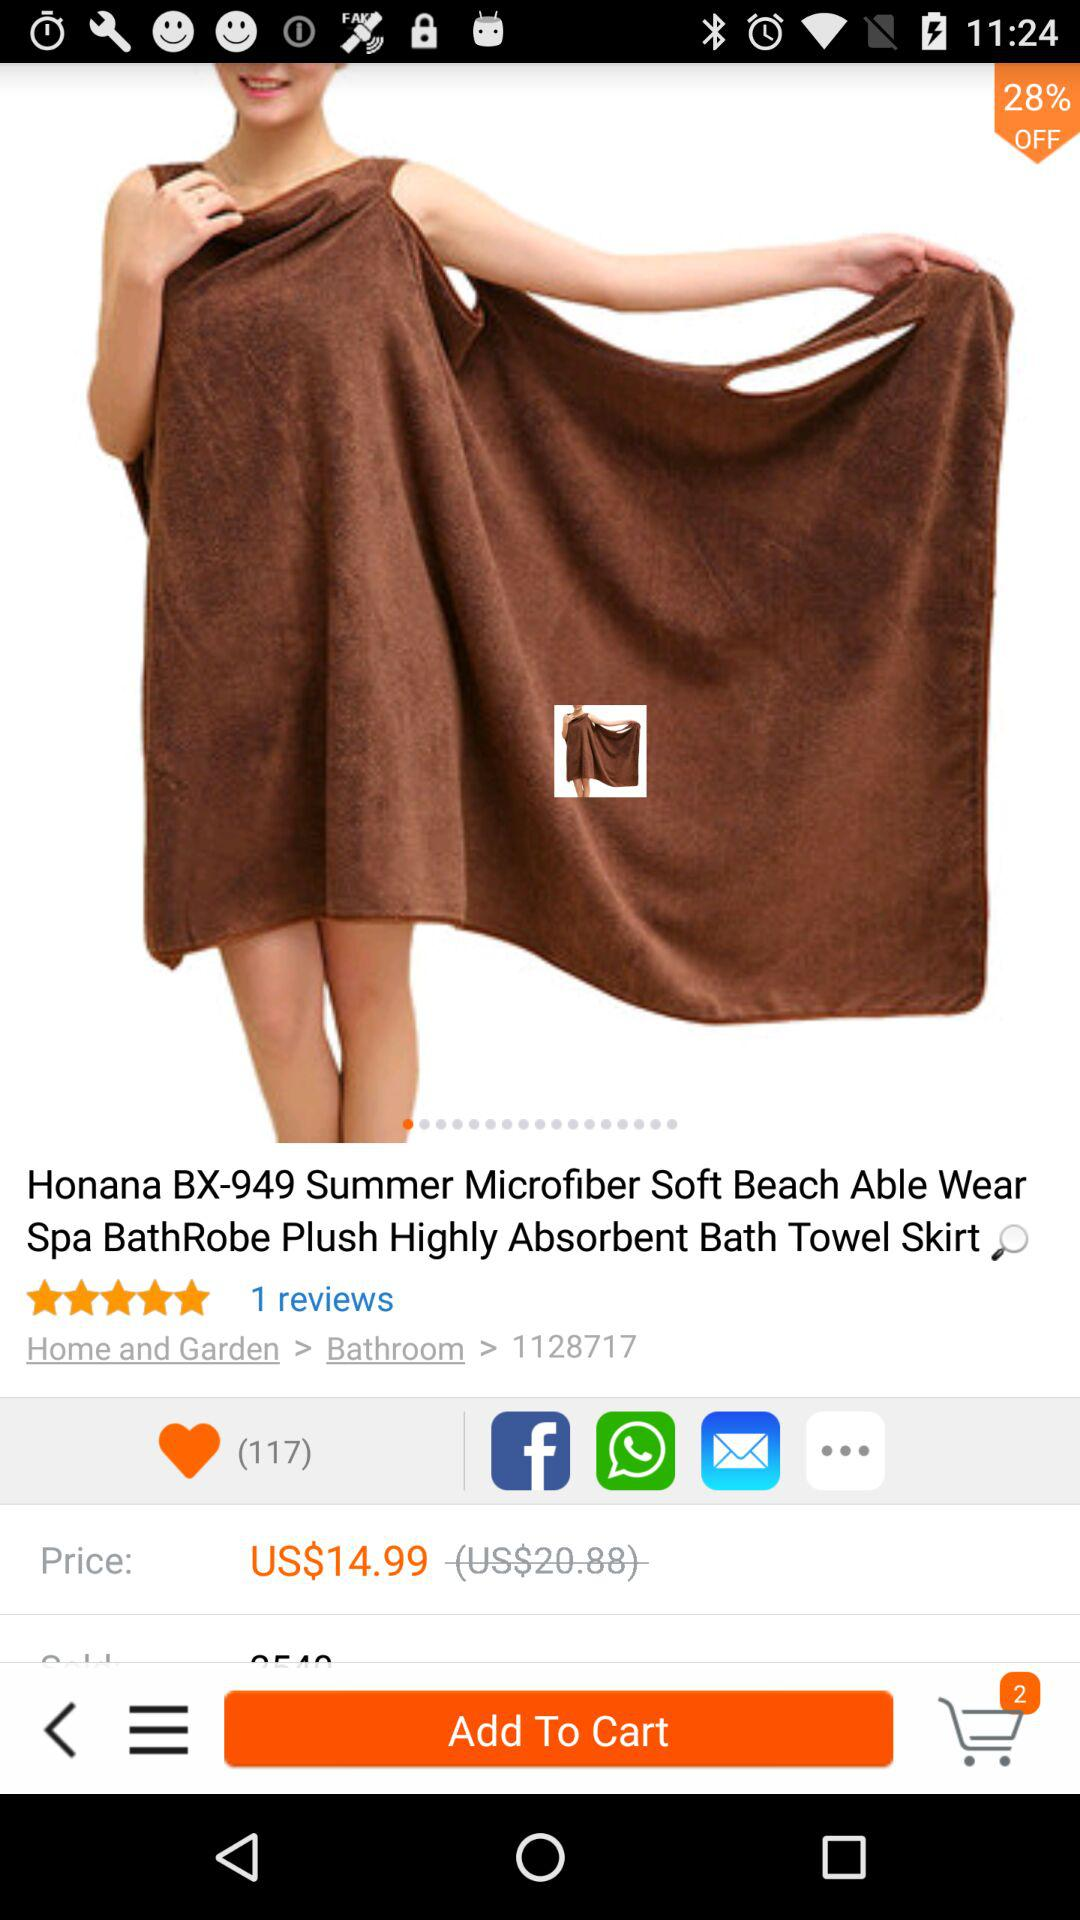How many items were added to the cart? There were 2 items added. 